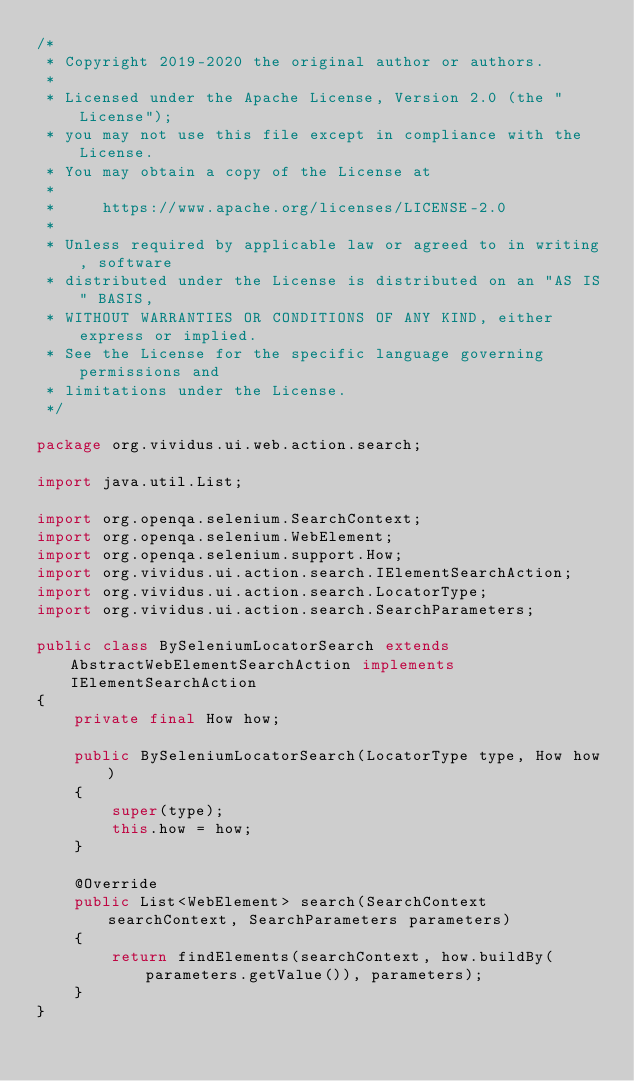<code> <loc_0><loc_0><loc_500><loc_500><_Java_>/*
 * Copyright 2019-2020 the original author or authors.
 *
 * Licensed under the Apache License, Version 2.0 (the "License");
 * you may not use this file except in compliance with the License.
 * You may obtain a copy of the License at
 *
 *     https://www.apache.org/licenses/LICENSE-2.0
 *
 * Unless required by applicable law or agreed to in writing, software
 * distributed under the License is distributed on an "AS IS" BASIS,
 * WITHOUT WARRANTIES OR CONDITIONS OF ANY KIND, either express or implied.
 * See the License for the specific language governing permissions and
 * limitations under the License.
 */

package org.vividus.ui.web.action.search;

import java.util.List;

import org.openqa.selenium.SearchContext;
import org.openqa.selenium.WebElement;
import org.openqa.selenium.support.How;
import org.vividus.ui.action.search.IElementSearchAction;
import org.vividus.ui.action.search.LocatorType;
import org.vividus.ui.action.search.SearchParameters;

public class BySeleniumLocatorSearch extends AbstractWebElementSearchAction implements IElementSearchAction
{
    private final How how;

    public BySeleniumLocatorSearch(LocatorType type, How how)
    {
        super(type);
        this.how = how;
    }

    @Override
    public List<WebElement> search(SearchContext searchContext, SearchParameters parameters)
    {
        return findElements(searchContext, how.buildBy(parameters.getValue()), parameters);
    }
}
</code> 